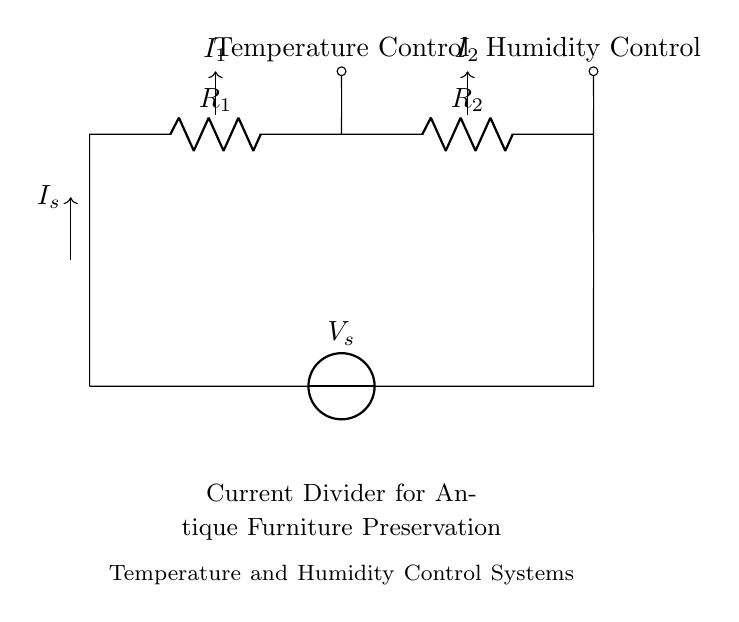What are the two control systems represented in this circuit? The circuit includes two branches for control systems: one for temperature and the other for humidity. These are labeled clearly above the respective resistors.
Answer: Temperature Control, Humidity Control What is the total current supplied by the source? The total current in a current divider configuration is represented by the symbol I_s, which indicates the sum of currents flowing to both branches.
Answer: I_s How do the resistors R_1 and R_2 affect the current? In a current divider, the values of R_1 and R_2 determine how the total current I_s is divided between the two branches. A higher resistance will draw less current, while a lower resistance will draw more.
Answer: They affect the current division What determines the voltage across the resistors R_1 and R_2? The voltage across each resistor is determined by Ohm's Law, where V = I * R. The share of the total current flowing through each resistor, along with its resistance, determines the voltage drop.
Answer: Resistance and current If the resistance R_1 is doubled, what happens to the current I_1? When the resistance R_1 is doubled, the current I_1 decreases because current and resistance are inversely related in a current divider. The current through R_1 will be less than it was before.
Answer: I_1 decreases What type of circuit is represented here? This circuit is a current divider configuration, which is designed to split the total current into different paths based on the resistances present in each path.
Answer: Current divider 